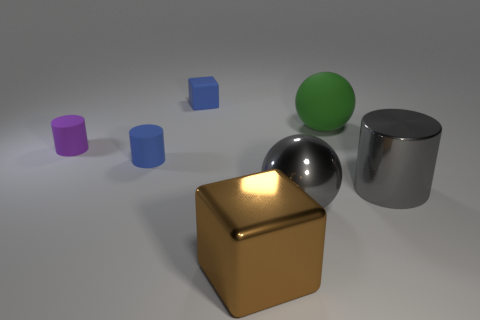What could be the purpose of arranging objects in this manner? This arrangement could serve as a visual demonstration of different geometric shapes and materials, potentially for educational purposes or a graphic design project. It highlights contrast, both in form and in the reflective properties of the surfaces, which might be useful for those studying 3D modeling or material properties in design. 